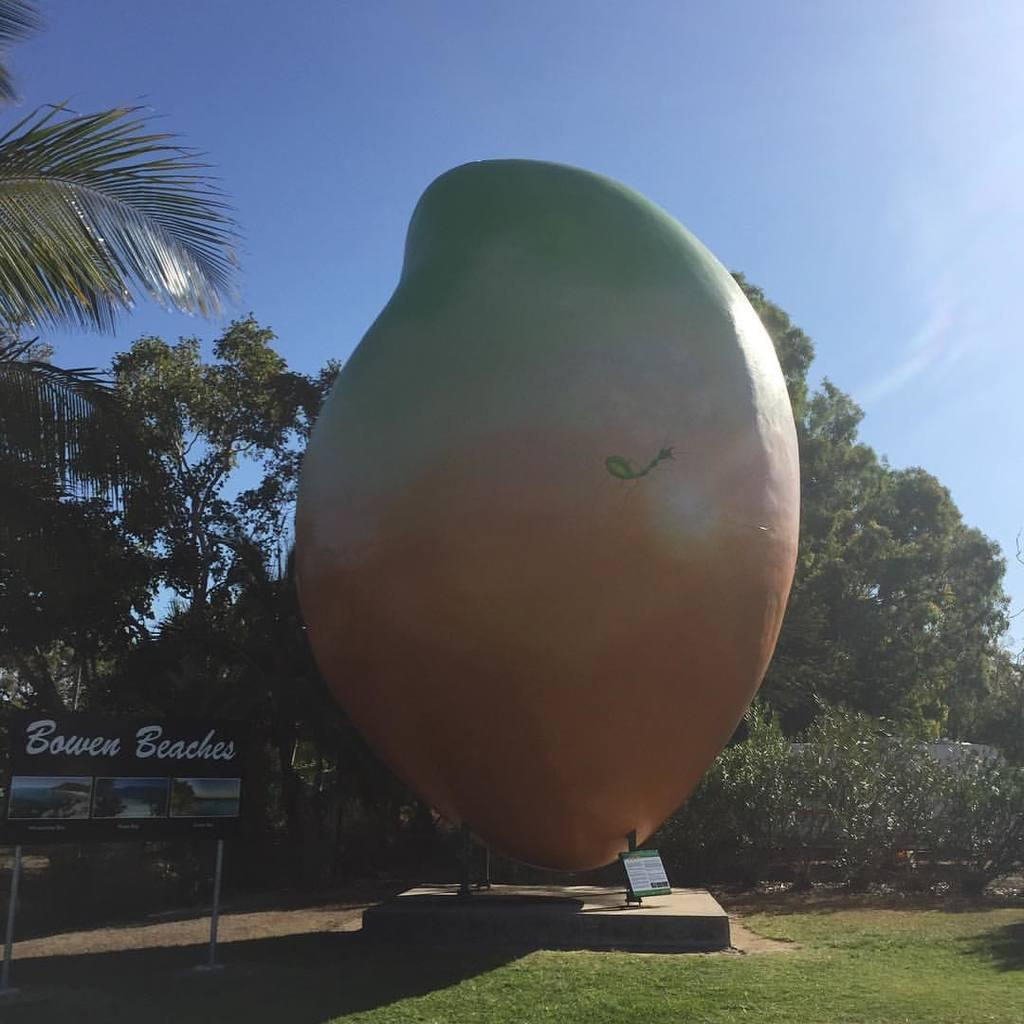What is located in the foreground of the image? There is an object and poles in the foreground of the image. What type of terrain is visible in the foreground of the image? There is grassland in the foreground of the image. What can be seen in the background of the image? There are trees, a poster, and the sky visible in the background of the image. What type of copy machine is present in the image? There is no copy machine present in the image. What type of border is visible around the poster in the image? The image does not provide information about the border around the poster. 